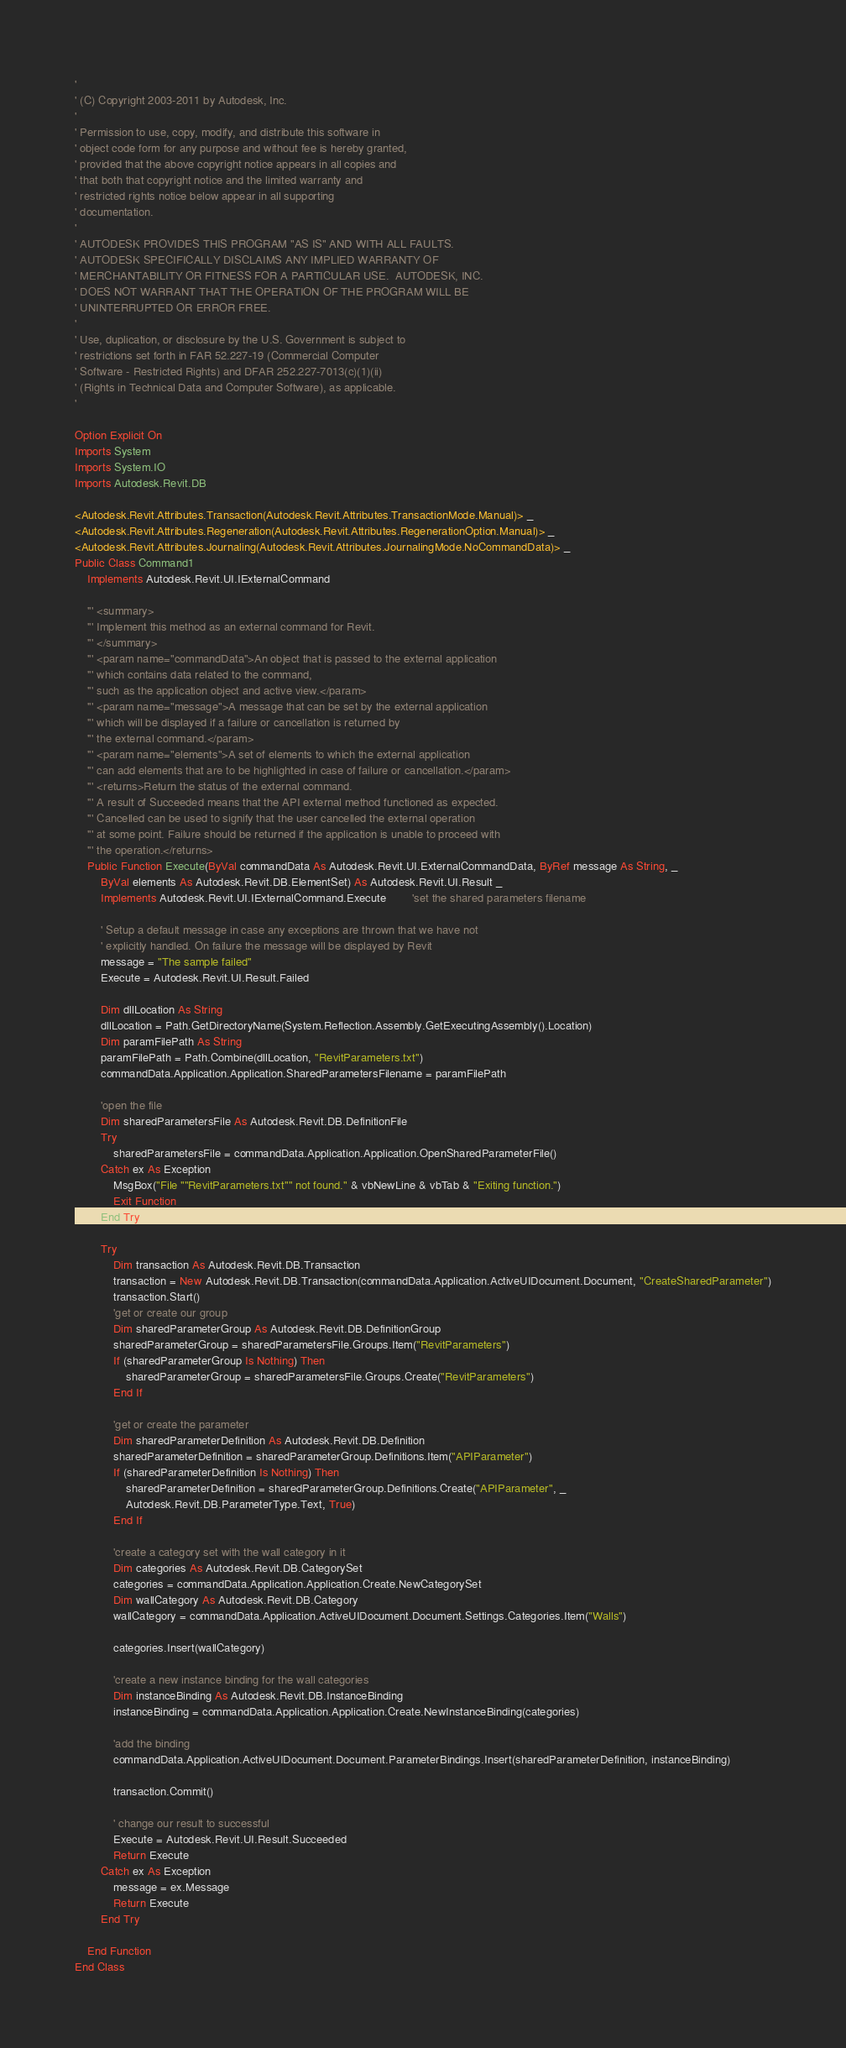<code> <loc_0><loc_0><loc_500><loc_500><_VisualBasic_>' 
' (C) Copyright 2003-2011 by Autodesk, Inc.
' 
' Permission to use, copy, modify, and distribute this software in
' object code form for any purpose and without fee is hereby granted,
' provided that the above copyright notice appears in all copies and
' that both that copyright notice and the limited warranty and
' restricted rights notice below appear in all supporting
' documentation.
'
' AUTODESK PROVIDES THIS PROGRAM "AS IS" AND WITH ALL FAULTS.
' AUTODESK SPECIFICALLY DISCLAIMS ANY IMPLIED WARRANTY OF
' MERCHANTABILITY OR FITNESS FOR A PARTICULAR USE.  AUTODESK, INC.
' DOES NOT WARRANT THAT THE OPERATION OF THE PROGRAM WILL BE
' UNINTERRUPTED OR ERROR FREE.
' 
' Use, duplication, or disclosure by the U.S. Government is subject to
' restrictions set forth in FAR 52.227-19 (Commercial Computer
' Software - Restricted Rights) and DFAR 252.227-7013(c)(1)(ii)
' (Rights in Technical Data and Computer Software), as applicable.
'

Option Explicit On
Imports System
Imports System.IO
Imports Autodesk.Revit.DB

<Autodesk.Revit.Attributes.Transaction(Autodesk.Revit.Attributes.TransactionMode.Manual)> _
<Autodesk.Revit.Attributes.Regeneration(Autodesk.Revit.Attributes.RegenerationOption.Manual)> _
<Autodesk.Revit.Attributes.Journaling(Autodesk.Revit.Attributes.JournalingMode.NoCommandData)> _
Public Class Command1
    Implements Autodesk.Revit.UI.IExternalCommand

    ''' <summary>
    ''' Implement this method as an external command for Revit.
    ''' </summary>
    ''' <param name="commandData">An object that is passed to the external application 
    ''' which contains data related to the command, 
    ''' such as the application object and active view.</param>
    ''' <param name="message">A message that can be set by the external application 
    ''' which will be displayed if a failure or cancellation is returned by 
    ''' the external command.</param>
    ''' <param name="elements">A set of elements to which the external application 
    ''' can add elements that are to be highlighted in case of failure or cancellation.</param>
    ''' <returns>Return the status of the external command. 
    ''' A result of Succeeded means that the API external method functioned as expected. 
    ''' Cancelled can be used to signify that the user cancelled the external operation 
    ''' at some point. Failure should be returned if the application is unable to proceed with 
    ''' the operation.</returns>
    Public Function Execute(ByVal commandData As Autodesk.Revit.UI.ExternalCommandData, ByRef message As String, _
        ByVal elements As Autodesk.Revit.DB.ElementSet) As Autodesk.Revit.UI.Result _
        Implements Autodesk.Revit.UI.IExternalCommand.Execute        'set the shared parameters filename

        ' Setup a default message in case any exceptions are thrown that we have not
        ' explicitly handled. On failure the message will be displayed by Revit
        message = "The sample failed"
        Execute = Autodesk.Revit.UI.Result.Failed

        Dim dllLocation As String
        dllLocation = Path.GetDirectoryName(System.Reflection.Assembly.GetExecutingAssembly().Location)
        Dim paramFilePath As String
        paramFilePath = Path.Combine(dllLocation, "RevitParameters.txt")
        commandData.Application.Application.SharedParametersFilename = paramFilePath

        'open the file
        Dim sharedParametersFile As Autodesk.Revit.DB.DefinitionFile
        Try
            sharedParametersFile = commandData.Application.Application.OpenSharedParameterFile()
        Catch ex As Exception
            MsgBox("File ""RevitParameters.txt"" not found." & vbNewLine & vbTab & "Exiting function.")
            Exit Function
        End Try

        Try
            Dim transaction As Autodesk.Revit.DB.Transaction
            transaction = New Autodesk.Revit.DB.Transaction(commandData.Application.ActiveUIDocument.Document, "CreateSharedParameter")
            transaction.Start()
            'get or create our group
            Dim sharedParameterGroup As Autodesk.Revit.DB.DefinitionGroup
            sharedParameterGroup = sharedParametersFile.Groups.Item("RevitParameters")
            If (sharedParameterGroup Is Nothing) Then
                sharedParameterGroup = sharedParametersFile.Groups.Create("RevitParameters")
            End If

            'get or create the parameter
            Dim sharedParameterDefinition As Autodesk.Revit.DB.Definition
            sharedParameterDefinition = sharedParameterGroup.Definitions.Item("APIParameter")
            If (sharedParameterDefinition Is Nothing) Then
                sharedParameterDefinition = sharedParameterGroup.Definitions.Create("APIParameter", _
                Autodesk.Revit.DB.ParameterType.Text, True)
            End If

            'create a category set with the wall category in it
            Dim categories As Autodesk.Revit.DB.CategorySet
            categories = commandData.Application.Application.Create.NewCategorySet
            Dim wallCategory As Autodesk.Revit.DB.Category
            wallCategory = commandData.Application.ActiveUIDocument.Document.Settings.Categories.Item("Walls")

            categories.Insert(wallCategory)

            'create a new instance binding for the wall categories
            Dim instanceBinding As Autodesk.Revit.DB.InstanceBinding
            instanceBinding = commandData.Application.Application.Create.NewInstanceBinding(categories)

            'add the binding
            commandData.Application.ActiveUIDocument.Document.ParameterBindings.Insert(sharedParameterDefinition, instanceBinding)

            transaction.Commit()

            ' change our result to successful
            Execute = Autodesk.Revit.UI.Result.Succeeded
            Return Execute
        Catch ex As Exception
            message = ex.Message
            Return Execute
        End Try

    End Function
End Class
</code> 